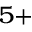<formula> <loc_0><loc_0><loc_500><loc_500>^ { 5 + }</formula> 